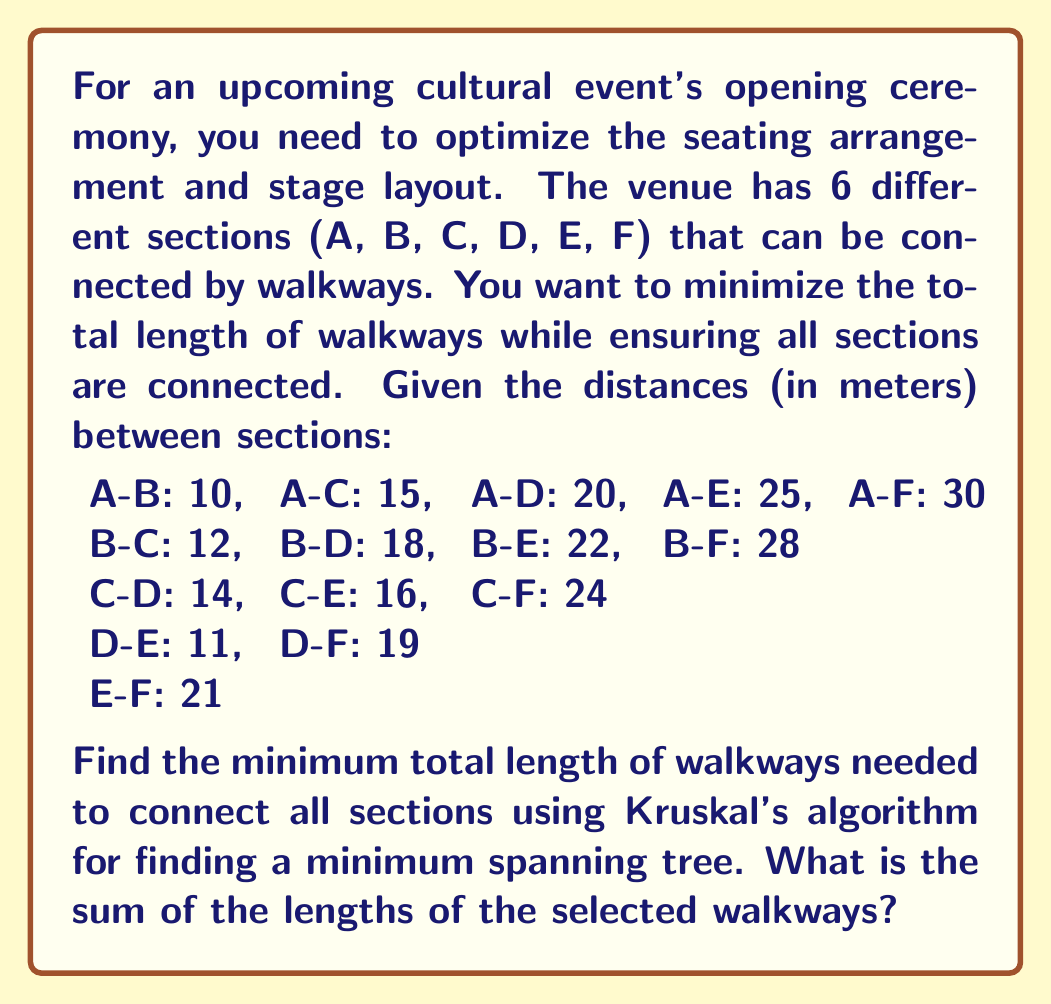Show me your answer to this math problem. To solve this problem, we'll use Kruskal's algorithm to find the minimum spanning tree of the graph representing the venue sections. This will give us the optimal layout with the minimum total length of walkways.

Steps:

1. List all edges (walkways) in ascending order of weight (length):
   D-E: 11
   B-C: 12
   C-D: 14
   A-B: 10
   C-E: 16
   B-D: 18
   D-F: 19
   A-C: 15
   E-F: 21
   B-E: 22
   A-D: 20
   C-F: 24
   A-E: 25
   B-F: 28
   A-F: 30

2. Initialize a disjoint set data structure for each vertex (section).

3. Iterate through the sorted list of edges:
   a. D-E: 11 (Add, connects D and E)
   b. B-C: 12 (Add, connects B and C)
   c. C-D: 14 (Add, connects {B,C} and {D,E})
   d. A-B: 10 (Add, connects A to {B,C,D,E})
   e. D-F: 19 (Add, connects F to {A,B,C,D,E})

4. Stop when all vertices are connected (we have 5 edges for 6 vertices).

5. Sum the lengths of the selected walkways:
   $$ 11 + 12 + 14 + 10 + 19 = 66 $$

The minimum spanning tree consists of the walkways:
A-B, B-C, C-D, D-E, and D-F, with a total length of 66 meters.
Answer: 66 meters 